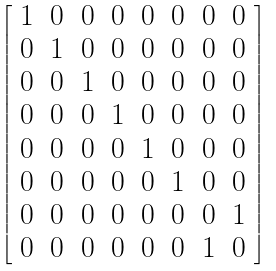<formula> <loc_0><loc_0><loc_500><loc_500>\left [ \begin{array} { l l l l l l l l } { 1 } & { 0 } & { 0 } & { 0 } & { 0 } & { 0 } & { 0 } & { 0 } \\ { 0 } & { 1 } & { 0 } & { 0 } & { 0 } & { 0 } & { 0 } & { 0 } \\ { 0 } & { 0 } & { 1 } & { 0 } & { 0 } & { 0 } & { 0 } & { 0 } \\ { 0 } & { 0 } & { 0 } & { 1 } & { 0 } & { 0 } & { 0 } & { 0 } \\ { 0 } & { 0 } & { 0 } & { 0 } & { 1 } & { 0 } & { 0 } & { 0 } \\ { 0 } & { 0 } & { 0 } & { 0 } & { 0 } & { 1 } & { 0 } & { 0 } \\ { 0 } & { 0 } & { 0 } & { 0 } & { 0 } & { 0 } & { 0 } & { 1 } \\ { 0 } & { 0 } & { 0 } & { 0 } & { 0 } & { 0 } & { 1 } & { 0 } \end{array} \right ]</formula> 